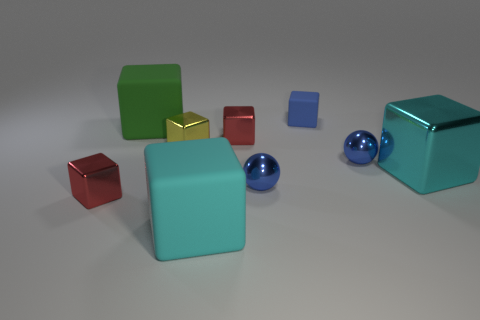Is there a red shiny cylinder that has the same size as the blue matte object?
Provide a succinct answer. No. What number of things are yellow shiny objects or big cyan metal cylinders?
Ensure brevity in your answer.  1. There is a metal cube that is to the right of the tiny rubber thing; is it the same size as the red metal object behind the tiny yellow object?
Make the answer very short. No. Is there a big blue object of the same shape as the tiny blue rubber object?
Your response must be concise. No. Is the number of small blue balls that are behind the large cyan shiny object less than the number of yellow cubes?
Provide a succinct answer. No. There is a blue sphere right of the small blue matte block; what is its size?
Offer a terse response. Small. What is the size of the blue thing that is made of the same material as the green object?
Your response must be concise. Small. Is the number of big cyan rubber things less than the number of large gray matte things?
Offer a very short reply. No. There is a green object that is the same size as the cyan matte block; what material is it?
Give a very brief answer. Rubber. Is the number of yellow metallic blocks greater than the number of tiny cyan balls?
Offer a very short reply. Yes. 